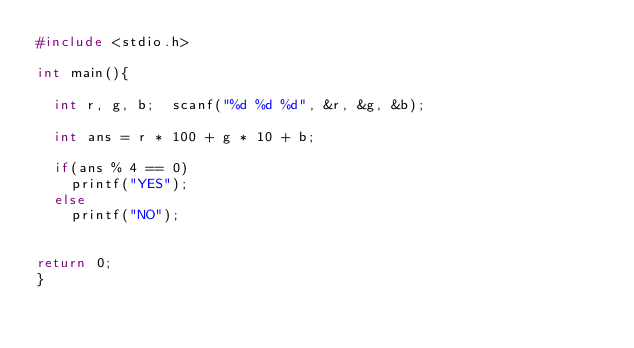Convert code to text. <code><loc_0><loc_0><loc_500><loc_500><_C++_>#include <stdio.h>

int main(){
	
	int r, g, b;	scanf("%d %d %d", &r, &g, &b);
	
	int ans = r * 100 + g * 10 + b;
	
	if(ans % 4 == 0)
		printf("YES");
	else
		printf("NO");
	
	
return 0;	
}
</code> 